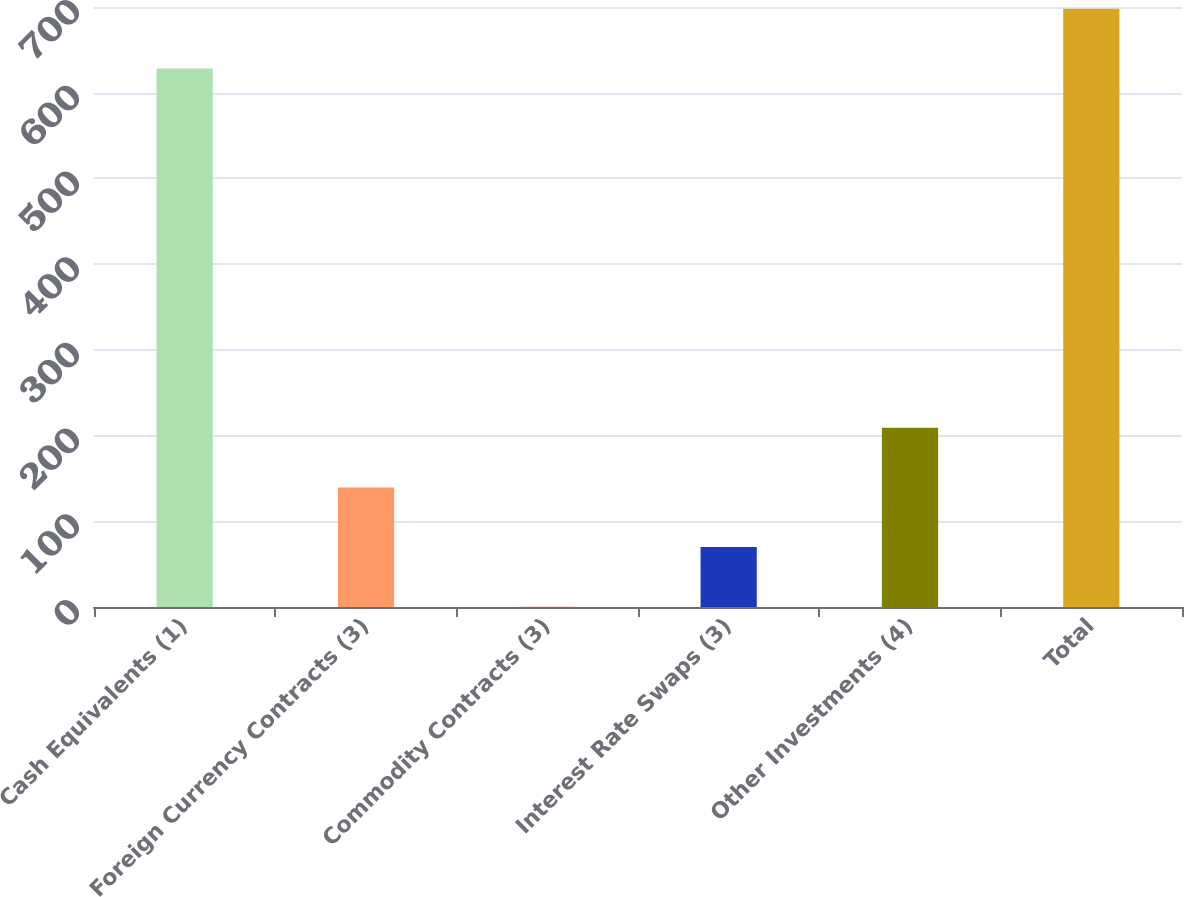<chart> <loc_0><loc_0><loc_500><loc_500><bar_chart><fcel>Cash Equivalents (1)<fcel>Foreign Currency Contracts (3)<fcel>Commodity Contracts (3)<fcel>Interest Rate Swaps (3)<fcel>Other Investments (4)<fcel>Total<nl><fcel>628.3<fcel>139.48<fcel>0.24<fcel>69.86<fcel>209.1<fcel>697.92<nl></chart> 